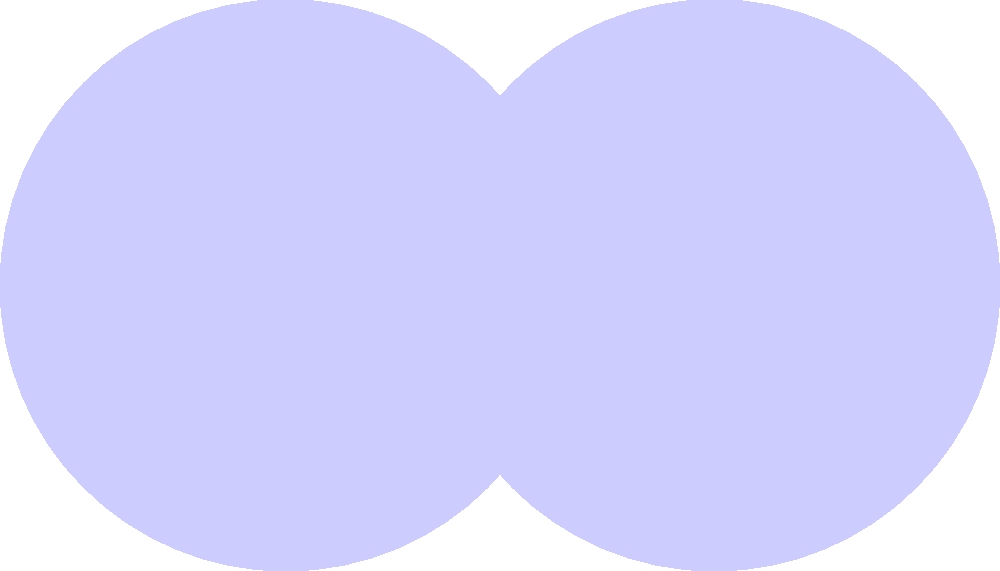Consider two circles $A$ and $B$ with radius $r=1$ and centers $(0,0)$ and $(1.5,0)$ respectively, as shown in the figure. Let $U$ be the union of the areas of both circles, and $I$ be their intersection. Express the area of $U$ in terms of $\pi$ and the area of $I$. Let's approach this step-by-step:

1) The area of a circle with radius $r$ is $\pi r^2$.

2) Each circle has an area of $\pi (1)^2 = \pi$.

3) The total area of both circles individually is $2\pi$.

4) However, this double-counts the intersection area $I$.

5) The area of the union $U$ is the sum of the areas of both circles, minus the area counted twice:

   $Area(U) = Area(A) + Area(B) - Area(I)$

6) Substituting the known values:

   $Area(U) = \pi + \pi - Area(I) = 2\pi - Area(I)$

7) Therefore, we can express the area of $U$ as:

   $Area(U) = 2\pi - Area(I)$

This solution elegantly combines geometric reasoning with set theory, expressing the union in terms of the individual sets and their intersection.
Answer: $2\pi - Area(I)$ 